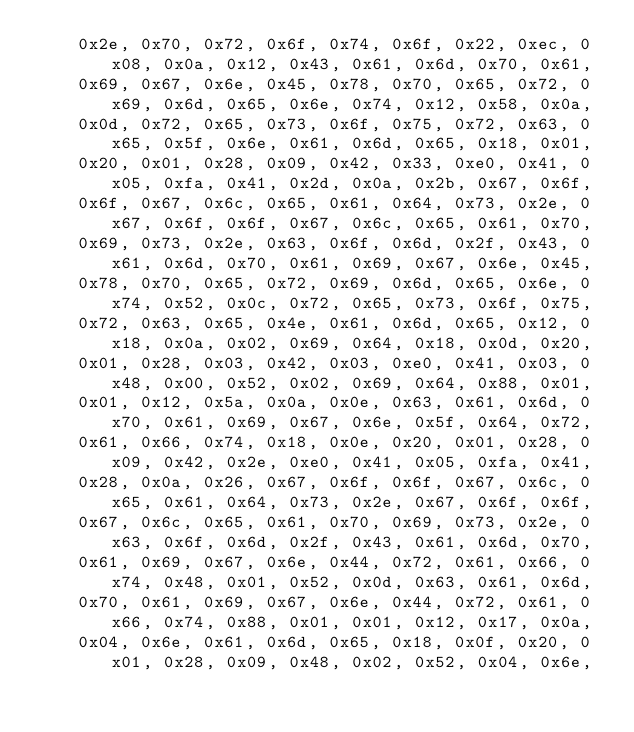Convert code to text. <code><loc_0><loc_0><loc_500><loc_500><_Go_>	0x2e, 0x70, 0x72, 0x6f, 0x74, 0x6f, 0x22, 0xec, 0x08, 0x0a, 0x12, 0x43, 0x61, 0x6d, 0x70, 0x61,
	0x69, 0x67, 0x6e, 0x45, 0x78, 0x70, 0x65, 0x72, 0x69, 0x6d, 0x65, 0x6e, 0x74, 0x12, 0x58, 0x0a,
	0x0d, 0x72, 0x65, 0x73, 0x6f, 0x75, 0x72, 0x63, 0x65, 0x5f, 0x6e, 0x61, 0x6d, 0x65, 0x18, 0x01,
	0x20, 0x01, 0x28, 0x09, 0x42, 0x33, 0xe0, 0x41, 0x05, 0xfa, 0x41, 0x2d, 0x0a, 0x2b, 0x67, 0x6f,
	0x6f, 0x67, 0x6c, 0x65, 0x61, 0x64, 0x73, 0x2e, 0x67, 0x6f, 0x6f, 0x67, 0x6c, 0x65, 0x61, 0x70,
	0x69, 0x73, 0x2e, 0x63, 0x6f, 0x6d, 0x2f, 0x43, 0x61, 0x6d, 0x70, 0x61, 0x69, 0x67, 0x6e, 0x45,
	0x78, 0x70, 0x65, 0x72, 0x69, 0x6d, 0x65, 0x6e, 0x74, 0x52, 0x0c, 0x72, 0x65, 0x73, 0x6f, 0x75,
	0x72, 0x63, 0x65, 0x4e, 0x61, 0x6d, 0x65, 0x12, 0x18, 0x0a, 0x02, 0x69, 0x64, 0x18, 0x0d, 0x20,
	0x01, 0x28, 0x03, 0x42, 0x03, 0xe0, 0x41, 0x03, 0x48, 0x00, 0x52, 0x02, 0x69, 0x64, 0x88, 0x01,
	0x01, 0x12, 0x5a, 0x0a, 0x0e, 0x63, 0x61, 0x6d, 0x70, 0x61, 0x69, 0x67, 0x6e, 0x5f, 0x64, 0x72,
	0x61, 0x66, 0x74, 0x18, 0x0e, 0x20, 0x01, 0x28, 0x09, 0x42, 0x2e, 0xe0, 0x41, 0x05, 0xfa, 0x41,
	0x28, 0x0a, 0x26, 0x67, 0x6f, 0x6f, 0x67, 0x6c, 0x65, 0x61, 0x64, 0x73, 0x2e, 0x67, 0x6f, 0x6f,
	0x67, 0x6c, 0x65, 0x61, 0x70, 0x69, 0x73, 0x2e, 0x63, 0x6f, 0x6d, 0x2f, 0x43, 0x61, 0x6d, 0x70,
	0x61, 0x69, 0x67, 0x6e, 0x44, 0x72, 0x61, 0x66, 0x74, 0x48, 0x01, 0x52, 0x0d, 0x63, 0x61, 0x6d,
	0x70, 0x61, 0x69, 0x67, 0x6e, 0x44, 0x72, 0x61, 0x66, 0x74, 0x88, 0x01, 0x01, 0x12, 0x17, 0x0a,
	0x04, 0x6e, 0x61, 0x6d, 0x65, 0x18, 0x0f, 0x20, 0x01, 0x28, 0x09, 0x48, 0x02, 0x52, 0x04, 0x6e,</code> 